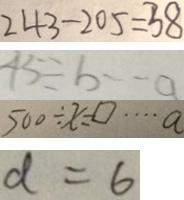<formula> <loc_0><loc_0><loc_500><loc_500>2 4 3 - 2 0 5 = 3 8 
 4 5 \div b \cdots a 
 5 0 0 \div x = \square \cdots a 
 d = 6</formula> 